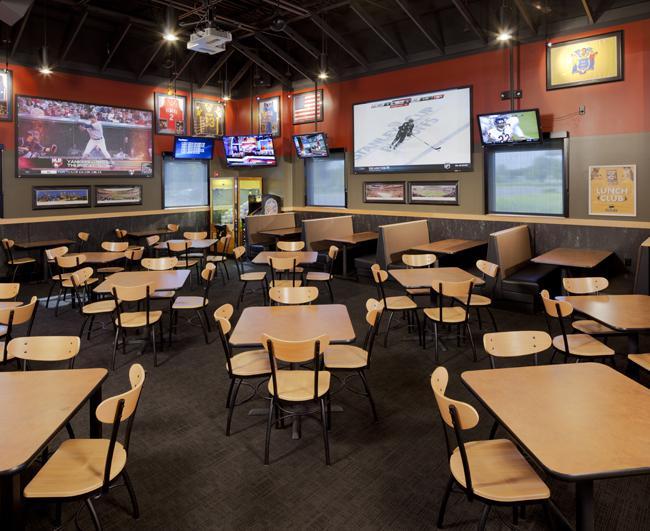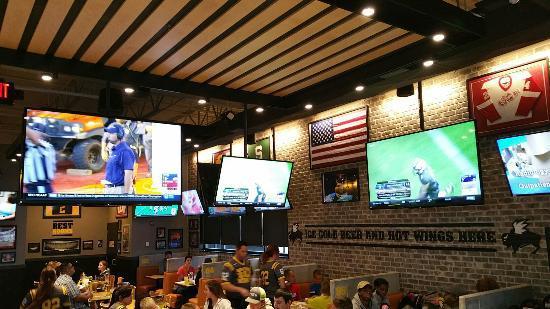The first image is the image on the left, the second image is the image on the right. For the images displayed, is the sentence "Right image shows a bar with an American flag high on the wall near multiple TV screens." factually correct? Answer yes or no. Yes. The first image is the image on the left, the second image is the image on the right. Analyze the images presented: Is the assertion "There are no people in either image." valid? Answer yes or no. No. 